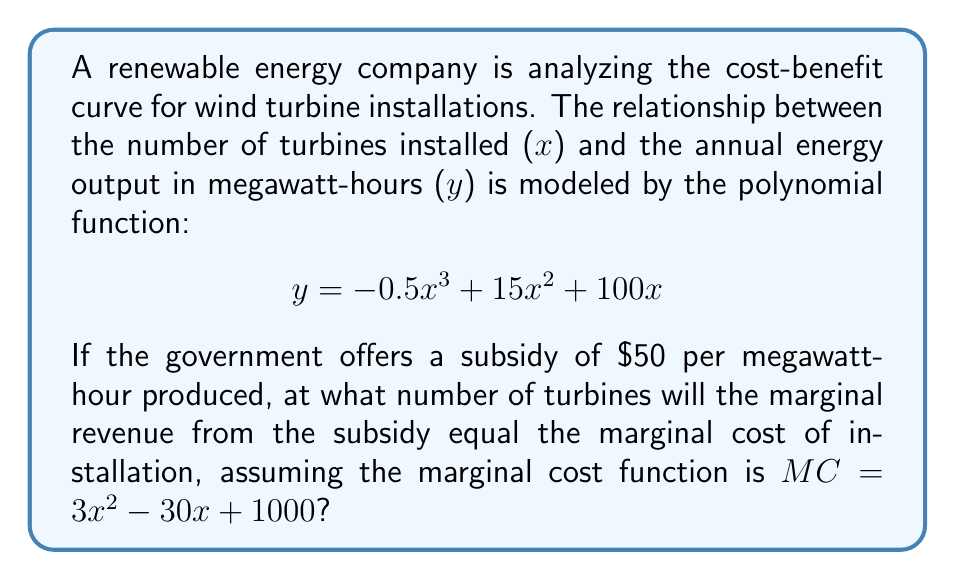Teach me how to tackle this problem. To solve this problem, we'll follow these steps:

1) First, we need to find the marginal revenue (MR) function. The revenue is the subsidy multiplied by the energy output:

   $R = 50y = 50(-0.5x^3 + 15x^2 + 100x)$
   $R = -25x^3 + 750x^2 + 5000x$

   The marginal revenue is the derivative of this:
   $MR = \frac{dR}{dx} = -75x^2 + 1500x + 5000$

2) We're given the marginal cost function:
   $MC = 3x^2 - 30x + 1000$

3) To find where marginal revenue equals marginal cost, we set these equal:

   $-75x^2 + 1500x + 5000 = 3x^2 - 30x + 1000$

4) Rearranging the equation:

   $-78x^2 + 1530x + 4000 = 0$

5) This is a quadratic equation. We can solve it using the quadratic formula:
   $x = \frac{-b \pm \sqrt{b^2 - 4ac}}{2a}$

   Where $a = -78$, $b = 1530$, and $c = 4000$

6) Plugging in these values:

   $x = \frac{-1530 \pm \sqrt{1530^2 - 4(-78)(4000)}}{2(-78)}$

7) Simplifying:

   $x = \frac{-1530 \pm \sqrt{2340900 + 1248000}}{-156}$
   $x = \frac{-1530 \pm \sqrt{3588900}}{-156}$
   $x = \frac{-1530 \pm 1894.44}{-156}$

8) This gives us two solutions:
   $x_1 = \frac{-1530 + 1894.44}{-156} \approx 2.34$
   $x_2 = \frac{-1530 - 1894.44}{-156} \approx 21.95$

9) Since we're dealing with the number of turbines, we round up to the nearest whole number. The smaller solution doesn't make sense in this context, so we use the larger one.
Answer: 22 turbines 